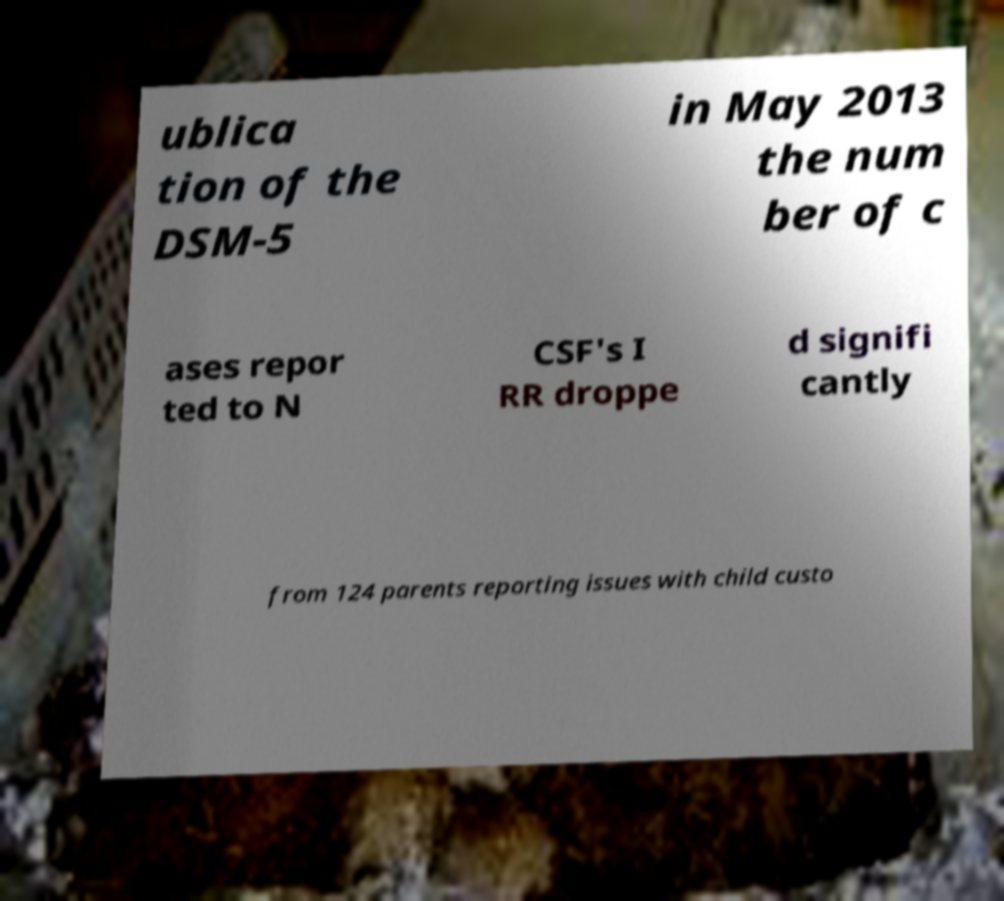For documentation purposes, I need the text within this image transcribed. Could you provide that? ublica tion of the DSM-5 in May 2013 the num ber of c ases repor ted to N CSF's I RR droppe d signifi cantly from 124 parents reporting issues with child custo 